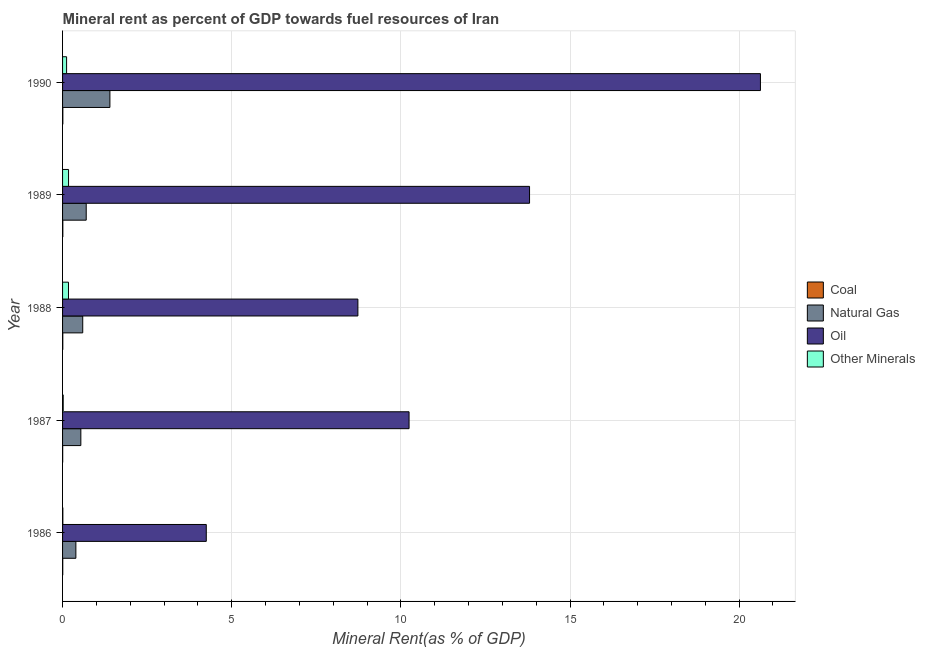How many different coloured bars are there?
Offer a terse response. 4. How many groups of bars are there?
Your answer should be compact. 5. Are the number of bars on each tick of the Y-axis equal?
Your response must be concise. Yes. How many bars are there on the 3rd tick from the bottom?
Provide a succinct answer. 4. What is the label of the 5th group of bars from the top?
Your answer should be very brief. 1986. What is the oil rent in 1988?
Ensure brevity in your answer.  8.73. Across all years, what is the maximum oil rent?
Your answer should be compact. 20.63. Across all years, what is the minimum natural gas rent?
Give a very brief answer. 0.39. In which year was the natural gas rent maximum?
Provide a succinct answer. 1990. What is the total oil rent in the graph?
Ensure brevity in your answer.  57.65. What is the difference between the oil rent in 1989 and that in 1990?
Provide a short and direct response. -6.83. What is the difference between the coal rent in 1988 and the  rent of other minerals in 1986?
Keep it short and to the point. -0. What is the average oil rent per year?
Make the answer very short. 11.53. In the year 1990, what is the difference between the oil rent and  rent of other minerals?
Your answer should be compact. 20.51. In how many years, is the oil rent greater than 15 %?
Provide a succinct answer. 1. What is the ratio of the oil rent in 1986 to that in 1988?
Give a very brief answer. 0.49. What is the difference between the highest and the second highest  rent of other minerals?
Your answer should be compact. 0. What is the difference between the highest and the lowest coal rent?
Make the answer very short. 0. Is the sum of the  rent of other minerals in 1989 and 1990 greater than the maximum coal rent across all years?
Offer a terse response. Yes. Is it the case that in every year, the sum of the coal rent and natural gas rent is greater than the sum of  rent of other minerals and oil rent?
Make the answer very short. Yes. What does the 1st bar from the top in 1987 represents?
Offer a terse response. Other Minerals. What does the 3rd bar from the bottom in 1990 represents?
Ensure brevity in your answer.  Oil. Is it the case that in every year, the sum of the coal rent and natural gas rent is greater than the oil rent?
Keep it short and to the point. No. How many years are there in the graph?
Offer a terse response. 5. How are the legend labels stacked?
Provide a short and direct response. Vertical. What is the title of the graph?
Your answer should be very brief. Mineral rent as percent of GDP towards fuel resources of Iran. What is the label or title of the X-axis?
Provide a succinct answer. Mineral Rent(as % of GDP). What is the label or title of the Y-axis?
Ensure brevity in your answer.  Year. What is the Mineral Rent(as % of GDP) of Coal in 1986?
Give a very brief answer. 0.01. What is the Mineral Rent(as % of GDP) of Natural Gas in 1986?
Your response must be concise. 0.39. What is the Mineral Rent(as % of GDP) in Oil in 1986?
Ensure brevity in your answer.  4.25. What is the Mineral Rent(as % of GDP) in Other Minerals in 1986?
Ensure brevity in your answer.  0.01. What is the Mineral Rent(as % of GDP) of Coal in 1987?
Keep it short and to the point. 0. What is the Mineral Rent(as % of GDP) of Natural Gas in 1987?
Your answer should be very brief. 0.54. What is the Mineral Rent(as % of GDP) in Oil in 1987?
Offer a very short reply. 10.24. What is the Mineral Rent(as % of GDP) in Other Minerals in 1987?
Your answer should be very brief. 0.02. What is the Mineral Rent(as % of GDP) of Coal in 1988?
Your answer should be compact. 0.01. What is the Mineral Rent(as % of GDP) in Natural Gas in 1988?
Offer a terse response. 0.6. What is the Mineral Rent(as % of GDP) of Oil in 1988?
Provide a succinct answer. 8.73. What is the Mineral Rent(as % of GDP) of Other Minerals in 1988?
Offer a terse response. 0.17. What is the Mineral Rent(as % of GDP) of Coal in 1989?
Offer a terse response. 0.01. What is the Mineral Rent(as % of GDP) in Natural Gas in 1989?
Make the answer very short. 0.7. What is the Mineral Rent(as % of GDP) of Oil in 1989?
Provide a short and direct response. 13.8. What is the Mineral Rent(as % of GDP) of Other Minerals in 1989?
Your response must be concise. 0.18. What is the Mineral Rent(as % of GDP) in Coal in 1990?
Your answer should be compact. 0.01. What is the Mineral Rent(as % of GDP) in Natural Gas in 1990?
Offer a terse response. 1.4. What is the Mineral Rent(as % of GDP) of Oil in 1990?
Give a very brief answer. 20.63. What is the Mineral Rent(as % of GDP) in Other Minerals in 1990?
Your answer should be compact. 0.12. Across all years, what is the maximum Mineral Rent(as % of GDP) in Coal?
Provide a short and direct response. 0.01. Across all years, what is the maximum Mineral Rent(as % of GDP) in Natural Gas?
Give a very brief answer. 1.4. Across all years, what is the maximum Mineral Rent(as % of GDP) in Oil?
Provide a short and direct response. 20.63. Across all years, what is the maximum Mineral Rent(as % of GDP) in Other Minerals?
Your answer should be compact. 0.18. Across all years, what is the minimum Mineral Rent(as % of GDP) in Coal?
Offer a terse response. 0. Across all years, what is the minimum Mineral Rent(as % of GDP) in Natural Gas?
Provide a succinct answer. 0.39. Across all years, what is the minimum Mineral Rent(as % of GDP) of Oil?
Give a very brief answer. 4.25. Across all years, what is the minimum Mineral Rent(as % of GDP) in Other Minerals?
Provide a short and direct response. 0.01. What is the total Mineral Rent(as % of GDP) of Coal in the graph?
Your response must be concise. 0.03. What is the total Mineral Rent(as % of GDP) of Natural Gas in the graph?
Give a very brief answer. 3.63. What is the total Mineral Rent(as % of GDP) in Oil in the graph?
Your answer should be very brief. 57.65. What is the total Mineral Rent(as % of GDP) of Other Minerals in the graph?
Provide a succinct answer. 0.5. What is the difference between the Mineral Rent(as % of GDP) of Coal in 1986 and that in 1987?
Your answer should be very brief. 0. What is the difference between the Mineral Rent(as % of GDP) of Natural Gas in 1986 and that in 1987?
Give a very brief answer. -0.15. What is the difference between the Mineral Rent(as % of GDP) of Oil in 1986 and that in 1987?
Offer a terse response. -5.99. What is the difference between the Mineral Rent(as % of GDP) in Other Minerals in 1986 and that in 1987?
Offer a terse response. -0.01. What is the difference between the Mineral Rent(as % of GDP) in Coal in 1986 and that in 1988?
Provide a succinct answer. -0. What is the difference between the Mineral Rent(as % of GDP) of Natural Gas in 1986 and that in 1988?
Give a very brief answer. -0.2. What is the difference between the Mineral Rent(as % of GDP) in Oil in 1986 and that in 1988?
Offer a very short reply. -4.48. What is the difference between the Mineral Rent(as % of GDP) in Other Minerals in 1986 and that in 1988?
Offer a very short reply. -0.17. What is the difference between the Mineral Rent(as % of GDP) of Coal in 1986 and that in 1989?
Make the answer very short. -0. What is the difference between the Mineral Rent(as % of GDP) of Natural Gas in 1986 and that in 1989?
Keep it short and to the point. -0.31. What is the difference between the Mineral Rent(as % of GDP) in Oil in 1986 and that in 1989?
Offer a terse response. -9.56. What is the difference between the Mineral Rent(as % of GDP) in Other Minerals in 1986 and that in 1989?
Provide a short and direct response. -0.17. What is the difference between the Mineral Rent(as % of GDP) in Coal in 1986 and that in 1990?
Keep it short and to the point. -0. What is the difference between the Mineral Rent(as % of GDP) of Natural Gas in 1986 and that in 1990?
Provide a succinct answer. -1.01. What is the difference between the Mineral Rent(as % of GDP) in Oil in 1986 and that in 1990?
Offer a very short reply. -16.38. What is the difference between the Mineral Rent(as % of GDP) in Other Minerals in 1986 and that in 1990?
Keep it short and to the point. -0.11. What is the difference between the Mineral Rent(as % of GDP) of Coal in 1987 and that in 1988?
Offer a terse response. -0. What is the difference between the Mineral Rent(as % of GDP) of Natural Gas in 1987 and that in 1988?
Make the answer very short. -0.06. What is the difference between the Mineral Rent(as % of GDP) in Oil in 1987 and that in 1988?
Offer a very short reply. 1.51. What is the difference between the Mineral Rent(as % of GDP) in Other Minerals in 1987 and that in 1988?
Offer a very short reply. -0.16. What is the difference between the Mineral Rent(as % of GDP) of Coal in 1987 and that in 1989?
Offer a very short reply. -0. What is the difference between the Mineral Rent(as % of GDP) of Natural Gas in 1987 and that in 1989?
Ensure brevity in your answer.  -0.16. What is the difference between the Mineral Rent(as % of GDP) of Oil in 1987 and that in 1989?
Offer a terse response. -3.56. What is the difference between the Mineral Rent(as % of GDP) in Other Minerals in 1987 and that in 1989?
Give a very brief answer. -0.16. What is the difference between the Mineral Rent(as % of GDP) of Coal in 1987 and that in 1990?
Offer a terse response. -0. What is the difference between the Mineral Rent(as % of GDP) of Natural Gas in 1987 and that in 1990?
Ensure brevity in your answer.  -0.86. What is the difference between the Mineral Rent(as % of GDP) of Oil in 1987 and that in 1990?
Give a very brief answer. -10.39. What is the difference between the Mineral Rent(as % of GDP) in Other Minerals in 1987 and that in 1990?
Ensure brevity in your answer.  -0.1. What is the difference between the Mineral Rent(as % of GDP) in Coal in 1988 and that in 1989?
Provide a succinct answer. -0. What is the difference between the Mineral Rent(as % of GDP) of Natural Gas in 1988 and that in 1989?
Give a very brief answer. -0.1. What is the difference between the Mineral Rent(as % of GDP) in Oil in 1988 and that in 1989?
Keep it short and to the point. -5.07. What is the difference between the Mineral Rent(as % of GDP) in Other Minerals in 1988 and that in 1989?
Provide a succinct answer. -0. What is the difference between the Mineral Rent(as % of GDP) in Coal in 1988 and that in 1990?
Keep it short and to the point. -0. What is the difference between the Mineral Rent(as % of GDP) in Natural Gas in 1988 and that in 1990?
Provide a succinct answer. -0.8. What is the difference between the Mineral Rent(as % of GDP) in Oil in 1988 and that in 1990?
Provide a short and direct response. -11.9. What is the difference between the Mineral Rent(as % of GDP) in Other Minerals in 1988 and that in 1990?
Keep it short and to the point. 0.06. What is the difference between the Mineral Rent(as % of GDP) of Coal in 1989 and that in 1990?
Your response must be concise. -0. What is the difference between the Mineral Rent(as % of GDP) in Natural Gas in 1989 and that in 1990?
Your answer should be very brief. -0.7. What is the difference between the Mineral Rent(as % of GDP) in Oil in 1989 and that in 1990?
Your response must be concise. -6.83. What is the difference between the Mineral Rent(as % of GDP) in Other Minerals in 1989 and that in 1990?
Offer a very short reply. 0.06. What is the difference between the Mineral Rent(as % of GDP) of Coal in 1986 and the Mineral Rent(as % of GDP) of Natural Gas in 1987?
Offer a terse response. -0.54. What is the difference between the Mineral Rent(as % of GDP) of Coal in 1986 and the Mineral Rent(as % of GDP) of Oil in 1987?
Your answer should be very brief. -10.24. What is the difference between the Mineral Rent(as % of GDP) in Coal in 1986 and the Mineral Rent(as % of GDP) in Other Minerals in 1987?
Your answer should be very brief. -0.01. What is the difference between the Mineral Rent(as % of GDP) in Natural Gas in 1986 and the Mineral Rent(as % of GDP) in Oil in 1987?
Make the answer very short. -9.85. What is the difference between the Mineral Rent(as % of GDP) in Natural Gas in 1986 and the Mineral Rent(as % of GDP) in Other Minerals in 1987?
Keep it short and to the point. 0.37. What is the difference between the Mineral Rent(as % of GDP) in Oil in 1986 and the Mineral Rent(as % of GDP) in Other Minerals in 1987?
Give a very brief answer. 4.23. What is the difference between the Mineral Rent(as % of GDP) in Coal in 1986 and the Mineral Rent(as % of GDP) in Natural Gas in 1988?
Your answer should be very brief. -0.59. What is the difference between the Mineral Rent(as % of GDP) in Coal in 1986 and the Mineral Rent(as % of GDP) in Oil in 1988?
Your answer should be very brief. -8.72. What is the difference between the Mineral Rent(as % of GDP) in Coal in 1986 and the Mineral Rent(as % of GDP) in Other Minerals in 1988?
Offer a terse response. -0.17. What is the difference between the Mineral Rent(as % of GDP) in Natural Gas in 1986 and the Mineral Rent(as % of GDP) in Oil in 1988?
Provide a succinct answer. -8.34. What is the difference between the Mineral Rent(as % of GDP) of Natural Gas in 1986 and the Mineral Rent(as % of GDP) of Other Minerals in 1988?
Offer a very short reply. 0.22. What is the difference between the Mineral Rent(as % of GDP) in Oil in 1986 and the Mineral Rent(as % of GDP) in Other Minerals in 1988?
Your answer should be very brief. 4.07. What is the difference between the Mineral Rent(as % of GDP) in Coal in 1986 and the Mineral Rent(as % of GDP) in Natural Gas in 1989?
Ensure brevity in your answer.  -0.69. What is the difference between the Mineral Rent(as % of GDP) of Coal in 1986 and the Mineral Rent(as % of GDP) of Oil in 1989?
Your response must be concise. -13.8. What is the difference between the Mineral Rent(as % of GDP) of Coal in 1986 and the Mineral Rent(as % of GDP) of Other Minerals in 1989?
Offer a terse response. -0.17. What is the difference between the Mineral Rent(as % of GDP) in Natural Gas in 1986 and the Mineral Rent(as % of GDP) in Oil in 1989?
Your answer should be compact. -13.41. What is the difference between the Mineral Rent(as % of GDP) in Natural Gas in 1986 and the Mineral Rent(as % of GDP) in Other Minerals in 1989?
Offer a terse response. 0.22. What is the difference between the Mineral Rent(as % of GDP) in Oil in 1986 and the Mineral Rent(as % of GDP) in Other Minerals in 1989?
Ensure brevity in your answer.  4.07. What is the difference between the Mineral Rent(as % of GDP) of Coal in 1986 and the Mineral Rent(as % of GDP) of Natural Gas in 1990?
Give a very brief answer. -1.39. What is the difference between the Mineral Rent(as % of GDP) of Coal in 1986 and the Mineral Rent(as % of GDP) of Oil in 1990?
Ensure brevity in your answer.  -20.62. What is the difference between the Mineral Rent(as % of GDP) in Coal in 1986 and the Mineral Rent(as % of GDP) in Other Minerals in 1990?
Keep it short and to the point. -0.11. What is the difference between the Mineral Rent(as % of GDP) in Natural Gas in 1986 and the Mineral Rent(as % of GDP) in Oil in 1990?
Provide a succinct answer. -20.24. What is the difference between the Mineral Rent(as % of GDP) of Natural Gas in 1986 and the Mineral Rent(as % of GDP) of Other Minerals in 1990?
Your answer should be very brief. 0.27. What is the difference between the Mineral Rent(as % of GDP) of Oil in 1986 and the Mineral Rent(as % of GDP) of Other Minerals in 1990?
Your answer should be very brief. 4.13. What is the difference between the Mineral Rent(as % of GDP) of Coal in 1987 and the Mineral Rent(as % of GDP) of Natural Gas in 1988?
Your answer should be very brief. -0.59. What is the difference between the Mineral Rent(as % of GDP) of Coal in 1987 and the Mineral Rent(as % of GDP) of Oil in 1988?
Your answer should be compact. -8.73. What is the difference between the Mineral Rent(as % of GDP) in Coal in 1987 and the Mineral Rent(as % of GDP) in Other Minerals in 1988?
Offer a very short reply. -0.17. What is the difference between the Mineral Rent(as % of GDP) of Natural Gas in 1987 and the Mineral Rent(as % of GDP) of Oil in 1988?
Offer a very short reply. -8.19. What is the difference between the Mineral Rent(as % of GDP) in Natural Gas in 1987 and the Mineral Rent(as % of GDP) in Other Minerals in 1988?
Your answer should be compact. 0.37. What is the difference between the Mineral Rent(as % of GDP) of Oil in 1987 and the Mineral Rent(as % of GDP) of Other Minerals in 1988?
Ensure brevity in your answer.  10.07. What is the difference between the Mineral Rent(as % of GDP) of Coal in 1987 and the Mineral Rent(as % of GDP) of Natural Gas in 1989?
Your answer should be very brief. -0.7. What is the difference between the Mineral Rent(as % of GDP) in Coal in 1987 and the Mineral Rent(as % of GDP) in Oil in 1989?
Your answer should be very brief. -13.8. What is the difference between the Mineral Rent(as % of GDP) of Coal in 1987 and the Mineral Rent(as % of GDP) of Other Minerals in 1989?
Make the answer very short. -0.17. What is the difference between the Mineral Rent(as % of GDP) of Natural Gas in 1987 and the Mineral Rent(as % of GDP) of Oil in 1989?
Provide a short and direct response. -13.26. What is the difference between the Mineral Rent(as % of GDP) in Natural Gas in 1987 and the Mineral Rent(as % of GDP) in Other Minerals in 1989?
Your answer should be compact. 0.36. What is the difference between the Mineral Rent(as % of GDP) of Oil in 1987 and the Mineral Rent(as % of GDP) of Other Minerals in 1989?
Offer a terse response. 10.07. What is the difference between the Mineral Rent(as % of GDP) in Coal in 1987 and the Mineral Rent(as % of GDP) in Natural Gas in 1990?
Provide a succinct answer. -1.4. What is the difference between the Mineral Rent(as % of GDP) in Coal in 1987 and the Mineral Rent(as % of GDP) in Oil in 1990?
Provide a succinct answer. -20.63. What is the difference between the Mineral Rent(as % of GDP) of Coal in 1987 and the Mineral Rent(as % of GDP) of Other Minerals in 1990?
Make the answer very short. -0.12. What is the difference between the Mineral Rent(as % of GDP) in Natural Gas in 1987 and the Mineral Rent(as % of GDP) in Oil in 1990?
Offer a very short reply. -20.09. What is the difference between the Mineral Rent(as % of GDP) of Natural Gas in 1987 and the Mineral Rent(as % of GDP) of Other Minerals in 1990?
Your answer should be very brief. 0.42. What is the difference between the Mineral Rent(as % of GDP) in Oil in 1987 and the Mineral Rent(as % of GDP) in Other Minerals in 1990?
Offer a terse response. 10.12. What is the difference between the Mineral Rent(as % of GDP) in Coal in 1988 and the Mineral Rent(as % of GDP) in Natural Gas in 1989?
Offer a terse response. -0.69. What is the difference between the Mineral Rent(as % of GDP) in Coal in 1988 and the Mineral Rent(as % of GDP) in Oil in 1989?
Offer a terse response. -13.8. What is the difference between the Mineral Rent(as % of GDP) in Coal in 1988 and the Mineral Rent(as % of GDP) in Other Minerals in 1989?
Ensure brevity in your answer.  -0.17. What is the difference between the Mineral Rent(as % of GDP) of Natural Gas in 1988 and the Mineral Rent(as % of GDP) of Oil in 1989?
Give a very brief answer. -13.21. What is the difference between the Mineral Rent(as % of GDP) of Natural Gas in 1988 and the Mineral Rent(as % of GDP) of Other Minerals in 1989?
Offer a very short reply. 0.42. What is the difference between the Mineral Rent(as % of GDP) in Oil in 1988 and the Mineral Rent(as % of GDP) in Other Minerals in 1989?
Your answer should be compact. 8.55. What is the difference between the Mineral Rent(as % of GDP) in Coal in 1988 and the Mineral Rent(as % of GDP) in Natural Gas in 1990?
Give a very brief answer. -1.39. What is the difference between the Mineral Rent(as % of GDP) in Coal in 1988 and the Mineral Rent(as % of GDP) in Oil in 1990?
Offer a terse response. -20.62. What is the difference between the Mineral Rent(as % of GDP) in Coal in 1988 and the Mineral Rent(as % of GDP) in Other Minerals in 1990?
Give a very brief answer. -0.11. What is the difference between the Mineral Rent(as % of GDP) of Natural Gas in 1988 and the Mineral Rent(as % of GDP) of Oil in 1990?
Offer a terse response. -20.03. What is the difference between the Mineral Rent(as % of GDP) in Natural Gas in 1988 and the Mineral Rent(as % of GDP) in Other Minerals in 1990?
Ensure brevity in your answer.  0.48. What is the difference between the Mineral Rent(as % of GDP) of Oil in 1988 and the Mineral Rent(as % of GDP) of Other Minerals in 1990?
Ensure brevity in your answer.  8.61. What is the difference between the Mineral Rent(as % of GDP) of Coal in 1989 and the Mineral Rent(as % of GDP) of Natural Gas in 1990?
Your answer should be compact. -1.39. What is the difference between the Mineral Rent(as % of GDP) in Coal in 1989 and the Mineral Rent(as % of GDP) in Oil in 1990?
Keep it short and to the point. -20.62. What is the difference between the Mineral Rent(as % of GDP) in Coal in 1989 and the Mineral Rent(as % of GDP) in Other Minerals in 1990?
Offer a terse response. -0.11. What is the difference between the Mineral Rent(as % of GDP) of Natural Gas in 1989 and the Mineral Rent(as % of GDP) of Oil in 1990?
Keep it short and to the point. -19.93. What is the difference between the Mineral Rent(as % of GDP) of Natural Gas in 1989 and the Mineral Rent(as % of GDP) of Other Minerals in 1990?
Provide a short and direct response. 0.58. What is the difference between the Mineral Rent(as % of GDP) of Oil in 1989 and the Mineral Rent(as % of GDP) of Other Minerals in 1990?
Your answer should be compact. 13.69. What is the average Mineral Rent(as % of GDP) in Coal per year?
Keep it short and to the point. 0.01. What is the average Mineral Rent(as % of GDP) in Natural Gas per year?
Keep it short and to the point. 0.73. What is the average Mineral Rent(as % of GDP) in Oil per year?
Keep it short and to the point. 11.53. What is the average Mineral Rent(as % of GDP) in Other Minerals per year?
Give a very brief answer. 0.1. In the year 1986, what is the difference between the Mineral Rent(as % of GDP) in Coal and Mineral Rent(as % of GDP) in Natural Gas?
Provide a short and direct response. -0.39. In the year 1986, what is the difference between the Mineral Rent(as % of GDP) of Coal and Mineral Rent(as % of GDP) of Oil?
Give a very brief answer. -4.24. In the year 1986, what is the difference between the Mineral Rent(as % of GDP) of Coal and Mineral Rent(as % of GDP) of Other Minerals?
Provide a short and direct response. -0. In the year 1986, what is the difference between the Mineral Rent(as % of GDP) of Natural Gas and Mineral Rent(as % of GDP) of Oil?
Offer a terse response. -3.86. In the year 1986, what is the difference between the Mineral Rent(as % of GDP) of Natural Gas and Mineral Rent(as % of GDP) of Other Minerals?
Your answer should be compact. 0.39. In the year 1986, what is the difference between the Mineral Rent(as % of GDP) of Oil and Mineral Rent(as % of GDP) of Other Minerals?
Offer a very short reply. 4.24. In the year 1987, what is the difference between the Mineral Rent(as % of GDP) in Coal and Mineral Rent(as % of GDP) in Natural Gas?
Offer a terse response. -0.54. In the year 1987, what is the difference between the Mineral Rent(as % of GDP) of Coal and Mineral Rent(as % of GDP) of Oil?
Your response must be concise. -10.24. In the year 1987, what is the difference between the Mineral Rent(as % of GDP) in Coal and Mineral Rent(as % of GDP) in Other Minerals?
Your response must be concise. -0.02. In the year 1987, what is the difference between the Mineral Rent(as % of GDP) in Natural Gas and Mineral Rent(as % of GDP) in Oil?
Keep it short and to the point. -9.7. In the year 1987, what is the difference between the Mineral Rent(as % of GDP) in Natural Gas and Mineral Rent(as % of GDP) in Other Minerals?
Ensure brevity in your answer.  0.52. In the year 1987, what is the difference between the Mineral Rent(as % of GDP) in Oil and Mineral Rent(as % of GDP) in Other Minerals?
Offer a very short reply. 10.22. In the year 1988, what is the difference between the Mineral Rent(as % of GDP) in Coal and Mineral Rent(as % of GDP) in Natural Gas?
Provide a short and direct response. -0.59. In the year 1988, what is the difference between the Mineral Rent(as % of GDP) in Coal and Mineral Rent(as % of GDP) in Oil?
Ensure brevity in your answer.  -8.72. In the year 1988, what is the difference between the Mineral Rent(as % of GDP) in Coal and Mineral Rent(as % of GDP) in Other Minerals?
Make the answer very short. -0.17. In the year 1988, what is the difference between the Mineral Rent(as % of GDP) of Natural Gas and Mineral Rent(as % of GDP) of Oil?
Keep it short and to the point. -8.13. In the year 1988, what is the difference between the Mineral Rent(as % of GDP) in Natural Gas and Mineral Rent(as % of GDP) in Other Minerals?
Your answer should be very brief. 0.42. In the year 1988, what is the difference between the Mineral Rent(as % of GDP) in Oil and Mineral Rent(as % of GDP) in Other Minerals?
Offer a very short reply. 8.55. In the year 1989, what is the difference between the Mineral Rent(as % of GDP) of Coal and Mineral Rent(as % of GDP) of Natural Gas?
Give a very brief answer. -0.69. In the year 1989, what is the difference between the Mineral Rent(as % of GDP) of Coal and Mineral Rent(as % of GDP) of Oil?
Provide a short and direct response. -13.8. In the year 1989, what is the difference between the Mineral Rent(as % of GDP) of Coal and Mineral Rent(as % of GDP) of Other Minerals?
Offer a very short reply. -0.17. In the year 1989, what is the difference between the Mineral Rent(as % of GDP) in Natural Gas and Mineral Rent(as % of GDP) in Oil?
Your answer should be compact. -13.1. In the year 1989, what is the difference between the Mineral Rent(as % of GDP) of Natural Gas and Mineral Rent(as % of GDP) of Other Minerals?
Keep it short and to the point. 0.52. In the year 1989, what is the difference between the Mineral Rent(as % of GDP) of Oil and Mineral Rent(as % of GDP) of Other Minerals?
Your response must be concise. 13.63. In the year 1990, what is the difference between the Mineral Rent(as % of GDP) of Coal and Mineral Rent(as % of GDP) of Natural Gas?
Make the answer very short. -1.39. In the year 1990, what is the difference between the Mineral Rent(as % of GDP) of Coal and Mineral Rent(as % of GDP) of Oil?
Your response must be concise. -20.62. In the year 1990, what is the difference between the Mineral Rent(as % of GDP) in Coal and Mineral Rent(as % of GDP) in Other Minerals?
Keep it short and to the point. -0.11. In the year 1990, what is the difference between the Mineral Rent(as % of GDP) of Natural Gas and Mineral Rent(as % of GDP) of Oil?
Make the answer very short. -19.23. In the year 1990, what is the difference between the Mineral Rent(as % of GDP) in Natural Gas and Mineral Rent(as % of GDP) in Other Minerals?
Your answer should be compact. 1.28. In the year 1990, what is the difference between the Mineral Rent(as % of GDP) in Oil and Mineral Rent(as % of GDP) in Other Minerals?
Offer a very short reply. 20.51. What is the ratio of the Mineral Rent(as % of GDP) in Coal in 1986 to that in 1987?
Ensure brevity in your answer.  1.54. What is the ratio of the Mineral Rent(as % of GDP) in Natural Gas in 1986 to that in 1987?
Offer a very short reply. 0.73. What is the ratio of the Mineral Rent(as % of GDP) of Oil in 1986 to that in 1987?
Ensure brevity in your answer.  0.41. What is the ratio of the Mineral Rent(as % of GDP) in Other Minerals in 1986 to that in 1987?
Give a very brief answer. 0.42. What is the ratio of the Mineral Rent(as % of GDP) of Coal in 1986 to that in 1988?
Keep it short and to the point. 0.76. What is the ratio of the Mineral Rent(as % of GDP) of Natural Gas in 1986 to that in 1988?
Provide a short and direct response. 0.66. What is the ratio of the Mineral Rent(as % of GDP) of Oil in 1986 to that in 1988?
Your answer should be compact. 0.49. What is the ratio of the Mineral Rent(as % of GDP) in Other Minerals in 1986 to that in 1988?
Keep it short and to the point. 0.05. What is the ratio of the Mineral Rent(as % of GDP) in Coal in 1986 to that in 1989?
Keep it short and to the point. 0.69. What is the ratio of the Mineral Rent(as % of GDP) in Natural Gas in 1986 to that in 1989?
Offer a terse response. 0.56. What is the ratio of the Mineral Rent(as % of GDP) in Oil in 1986 to that in 1989?
Keep it short and to the point. 0.31. What is the ratio of the Mineral Rent(as % of GDP) of Other Minerals in 1986 to that in 1989?
Offer a terse response. 0.05. What is the ratio of the Mineral Rent(as % of GDP) in Coal in 1986 to that in 1990?
Keep it short and to the point. 0.66. What is the ratio of the Mineral Rent(as % of GDP) in Natural Gas in 1986 to that in 1990?
Offer a terse response. 0.28. What is the ratio of the Mineral Rent(as % of GDP) in Oil in 1986 to that in 1990?
Ensure brevity in your answer.  0.21. What is the ratio of the Mineral Rent(as % of GDP) of Other Minerals in 1986 to that in 1990?
Your answer should be very brief. 0.07. What is the ratio of the Mineral Rent(as % of GDP) of Coal in 1987 to that in 1988?
Offer a terse response. 0.49. What is the ratio of the Mineral Rent(as % of GDP) of Natural Gas in 1987 to that in 1988?
Give a very brief answer. 0.91. What is the ratio of the Mineral Rent(as % of GDP) in Oil in 1987 to that in 1988?
Your response must be concise. 1.17. What is the ratio of the Mineral Rent(as % of GDP) of Other Minerals in 1987 to that in 1988?
Keep it short and to the point. 0.11. What is the ratio of the Mineral Rent(as % of GDP) of Coal in 1987 to that in 1989?
Offer a very short reply. 0.45. What is the ratio of the Mineral Rent(as % of GDP) in Natural Gas in 1987 to that in 1989?
Your response must be concise. 0.77. What is the ratio of the Mineral Rent(as % of GDP) in Oil in 1987 to that in 1989?
Your answer should be very brief. 0.74. What is the ratio of the Mineral Rent(as % of GDP) in Other Minerals in 1987 to that in 1989?
Keep it short and to the point. 0.11. What is the ratio of the Mineral Rent(as % of GDP) of Coal in 1987 to that in 1990?
Offer a very short reply. 0.43. What is the ratio of the Mineral Rent(as % of GDP) in Natural Gas in 1987 to that in 1990?
Provide a short and direct response. 0.39. What is the ratio of the Mineral Rent(as % of GDP) in Oil in 1987 to that in 1990?
Provide a short and direct response. 0.5. What is the ratio of the Mineral Rent(as % of GDP) in Other Minerals in 1987 to that in 1990?
Make the answer very short. 0.16. What is the ratio of the Mineral Rent(as % of GDP) of Coal in 1988 to that in 1989?
Your answer should be compact. 0.9. What is the ratio of the Mineral Rent(as % of GDP) of Natural Gas in 1988 to that in 1989?
Offer a terse response. 0.85. What is the ratio of the Mineral Rent(as % of GDP) of Oil in 1988 to that in 1989?
Offer a terse response. 0.63. What is the ratio of the Mineral Rent(as % of GDP) of Coal in 1988 to that in 1990?
Your answer should be very brief. 0.87. What is the ratio of the Mineral Rent(as % of GDP) of Natural Gas in 1988 to that in 1990?
Keep it short and to the point. 0.43. What is the ratio of the Mineral Rent(as % of GDP) of Oil in 1988 to that in 1990?
Make the answer very short. 0.42. What is the ratio of the Mineral Rent(as % of GDP) of Other Minerals in 1988 to that in 1990?
Provide a short and direct response. 1.47. What is the ratio of the Mineral Rent(as % of GDP) of Coal in 1989 to that in 1990?
Make the answer very short. 0.97. What is the ratio of the Mineral Rent(as % of GDP) in Natural Gas in 1989 to that in 1990?
Ensure brevity in your answer.  0.5. What is the ratio of the Mineral Rent(as % of GDP) of Oil in 1989 to that in 1990?
Keep it short and to the point. 0.67. What is the ratio of the Mineral Rent(as % of GDP) in Other Minerals in 1989 to that in 1990?
Make the answer very short. 1.48. What is the difference between the highest and the second highest Mineral Rent(as % of GDP) in Natural Gas?
Offer a very short reply. 0.7. What is the difference between the highest and the second highest Mineral Rent(as % of GDP) in Oil?
Keep it short and to the point. 6.83. What is the difference between the highest and the second highest Mineral Rent(as % of GDP) of Other Minerals?
Your response must be concise. 0. What is the difference between the highest and the lowest Mineral Rent(as % of GDP) of Coal?
Your answer should be very brief. 0. What is the difference between the highest and the lowest Mineral Rent(as % of GDP) in Oil?
Keep it short and to the point. 16.38. What is the difference between the highest and the lowest Mineral Rent(as % of GDP) of Other Minerals?
Your response must be concise. 0.17. 